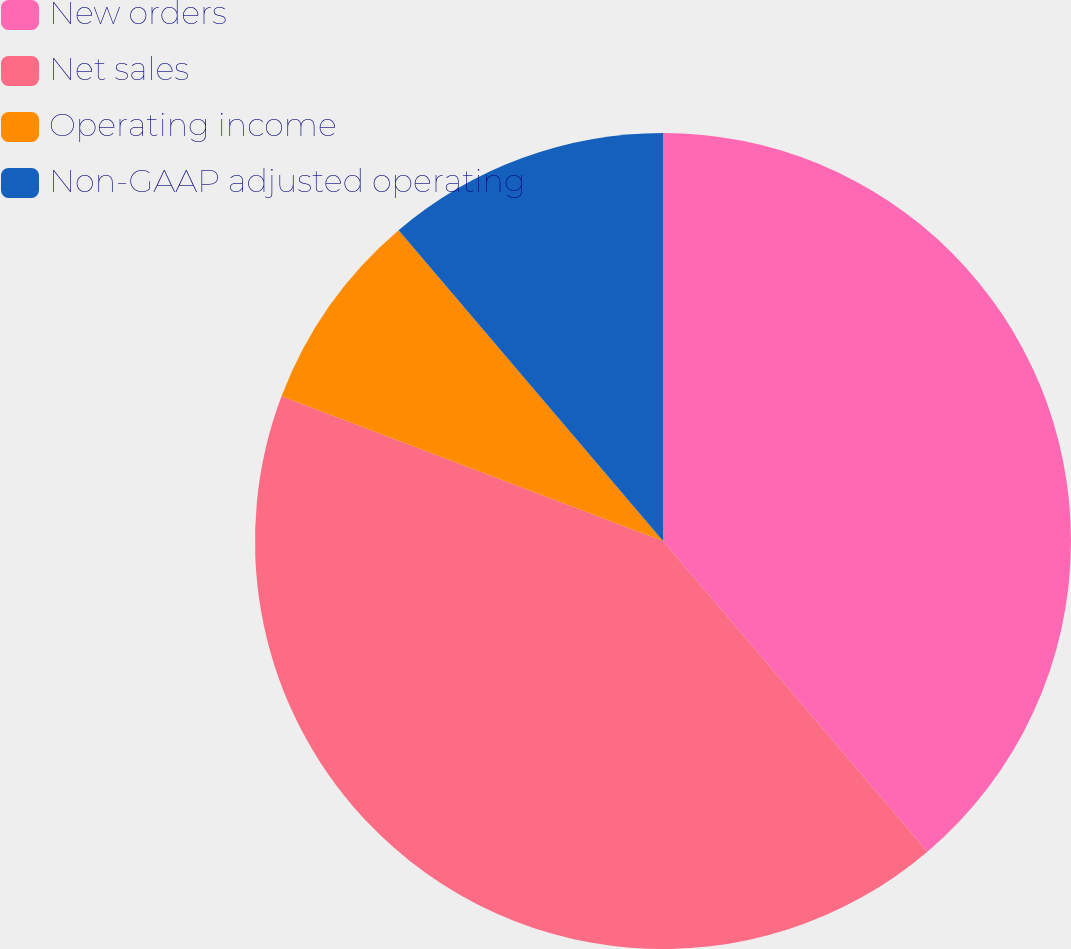Convert chart to OTSL. <chart><loc_0><loc_0><loc_500><loc_500><pie_chart><fcel>New orders<fcel>Net sales<fcel>Operating income<fcel>Non-GAAP adjusted operating<nl><fcel>38.78%<fcel>41.99%<fcel>8.01%<fcel>11.22%<nl></chart> 